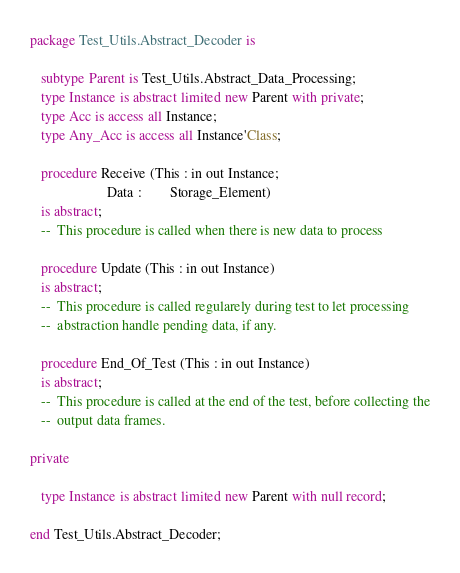Convert code to text. <code><loc_0><loc_0><loc_500><loc_500><_Ada_>package Test_Utils.Abstract_Decoder is

   subtype Parent is Test_Utils.Abstract_Data_Processing;
   type Instance is abstract limited new Parent with private;
   type Acc is access all Instance;
   type Any_Acc is access all Instance'Class;

   procedure Receive (This : in out Instance;
                      Data :        Storage_Element)
   is abstract;
   --  This procedure is called when there is new data to process

   procedure Update (This : in out Instance)
   is abstract;
   --  This procedure is called regularely during test to let processing
   --  abstraction handle pending data, if any.

   procedure End_Of_Test (This : in out Instance)
   is abstract;
   --  This procedure is called at the end of the test, before collecting the
   --  output data frames.

private

   type Instance is abstract limited new Parent with null record;

end Test_Utils.Abstract_Decoder;
</code> 